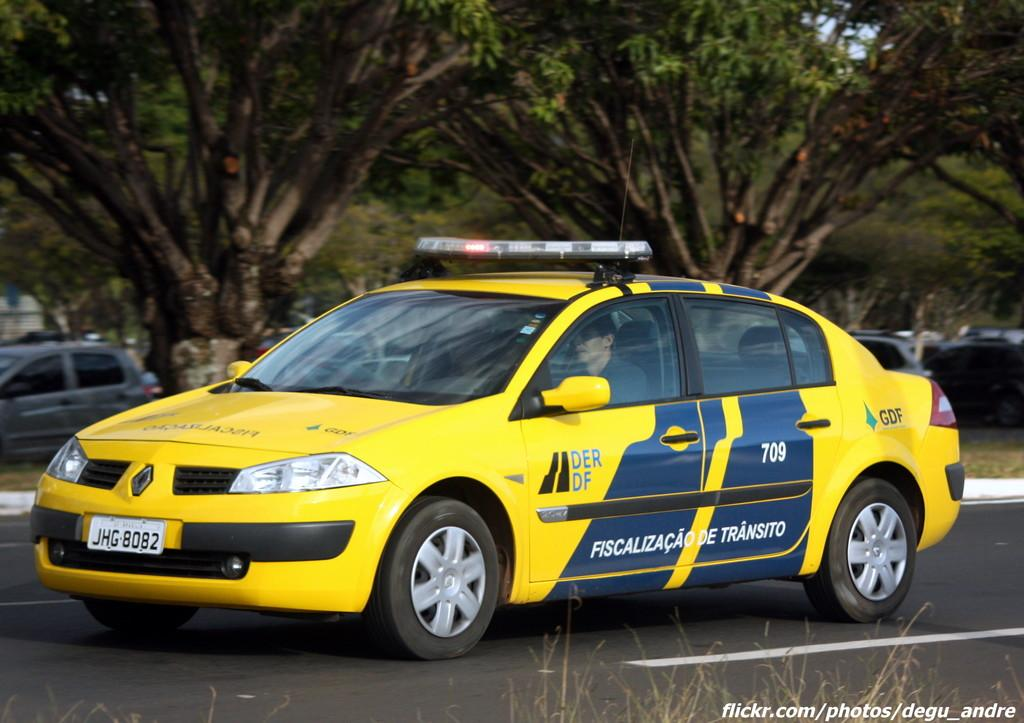<image>
Present a compact description of the photo's key features. A European police car with plate number JHG 8082 